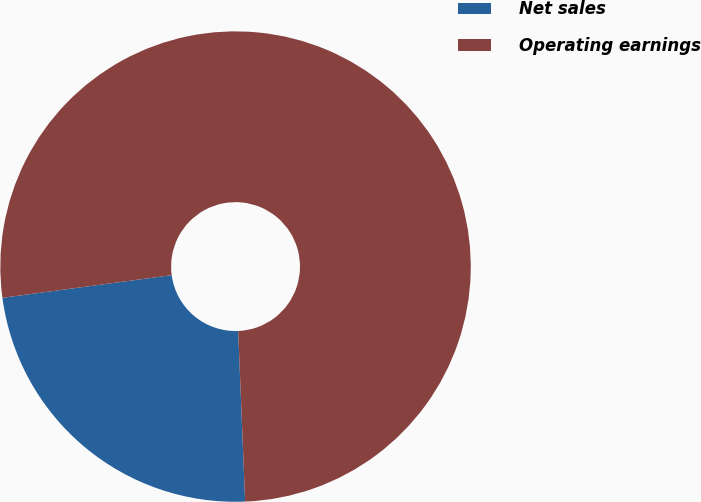<chart> <loc_0><loc_0><loc_500><loc_500><pie_chart><fcel>Net sales<fcel>Operating earnings<nl><fcel>23.53%<fcel>76.47%<nl></chart> 